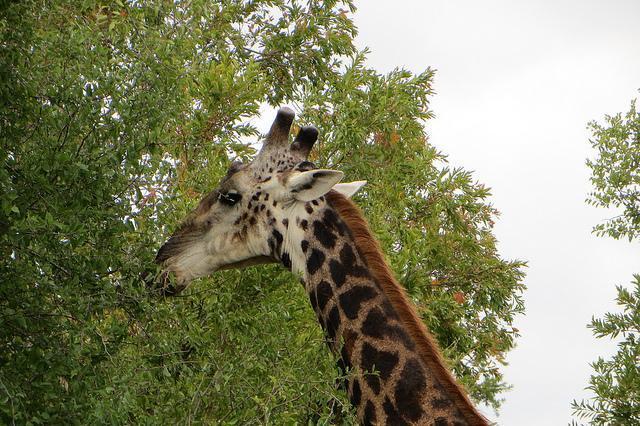How many birds are in the picture?
Give a very brief answer. 0. 